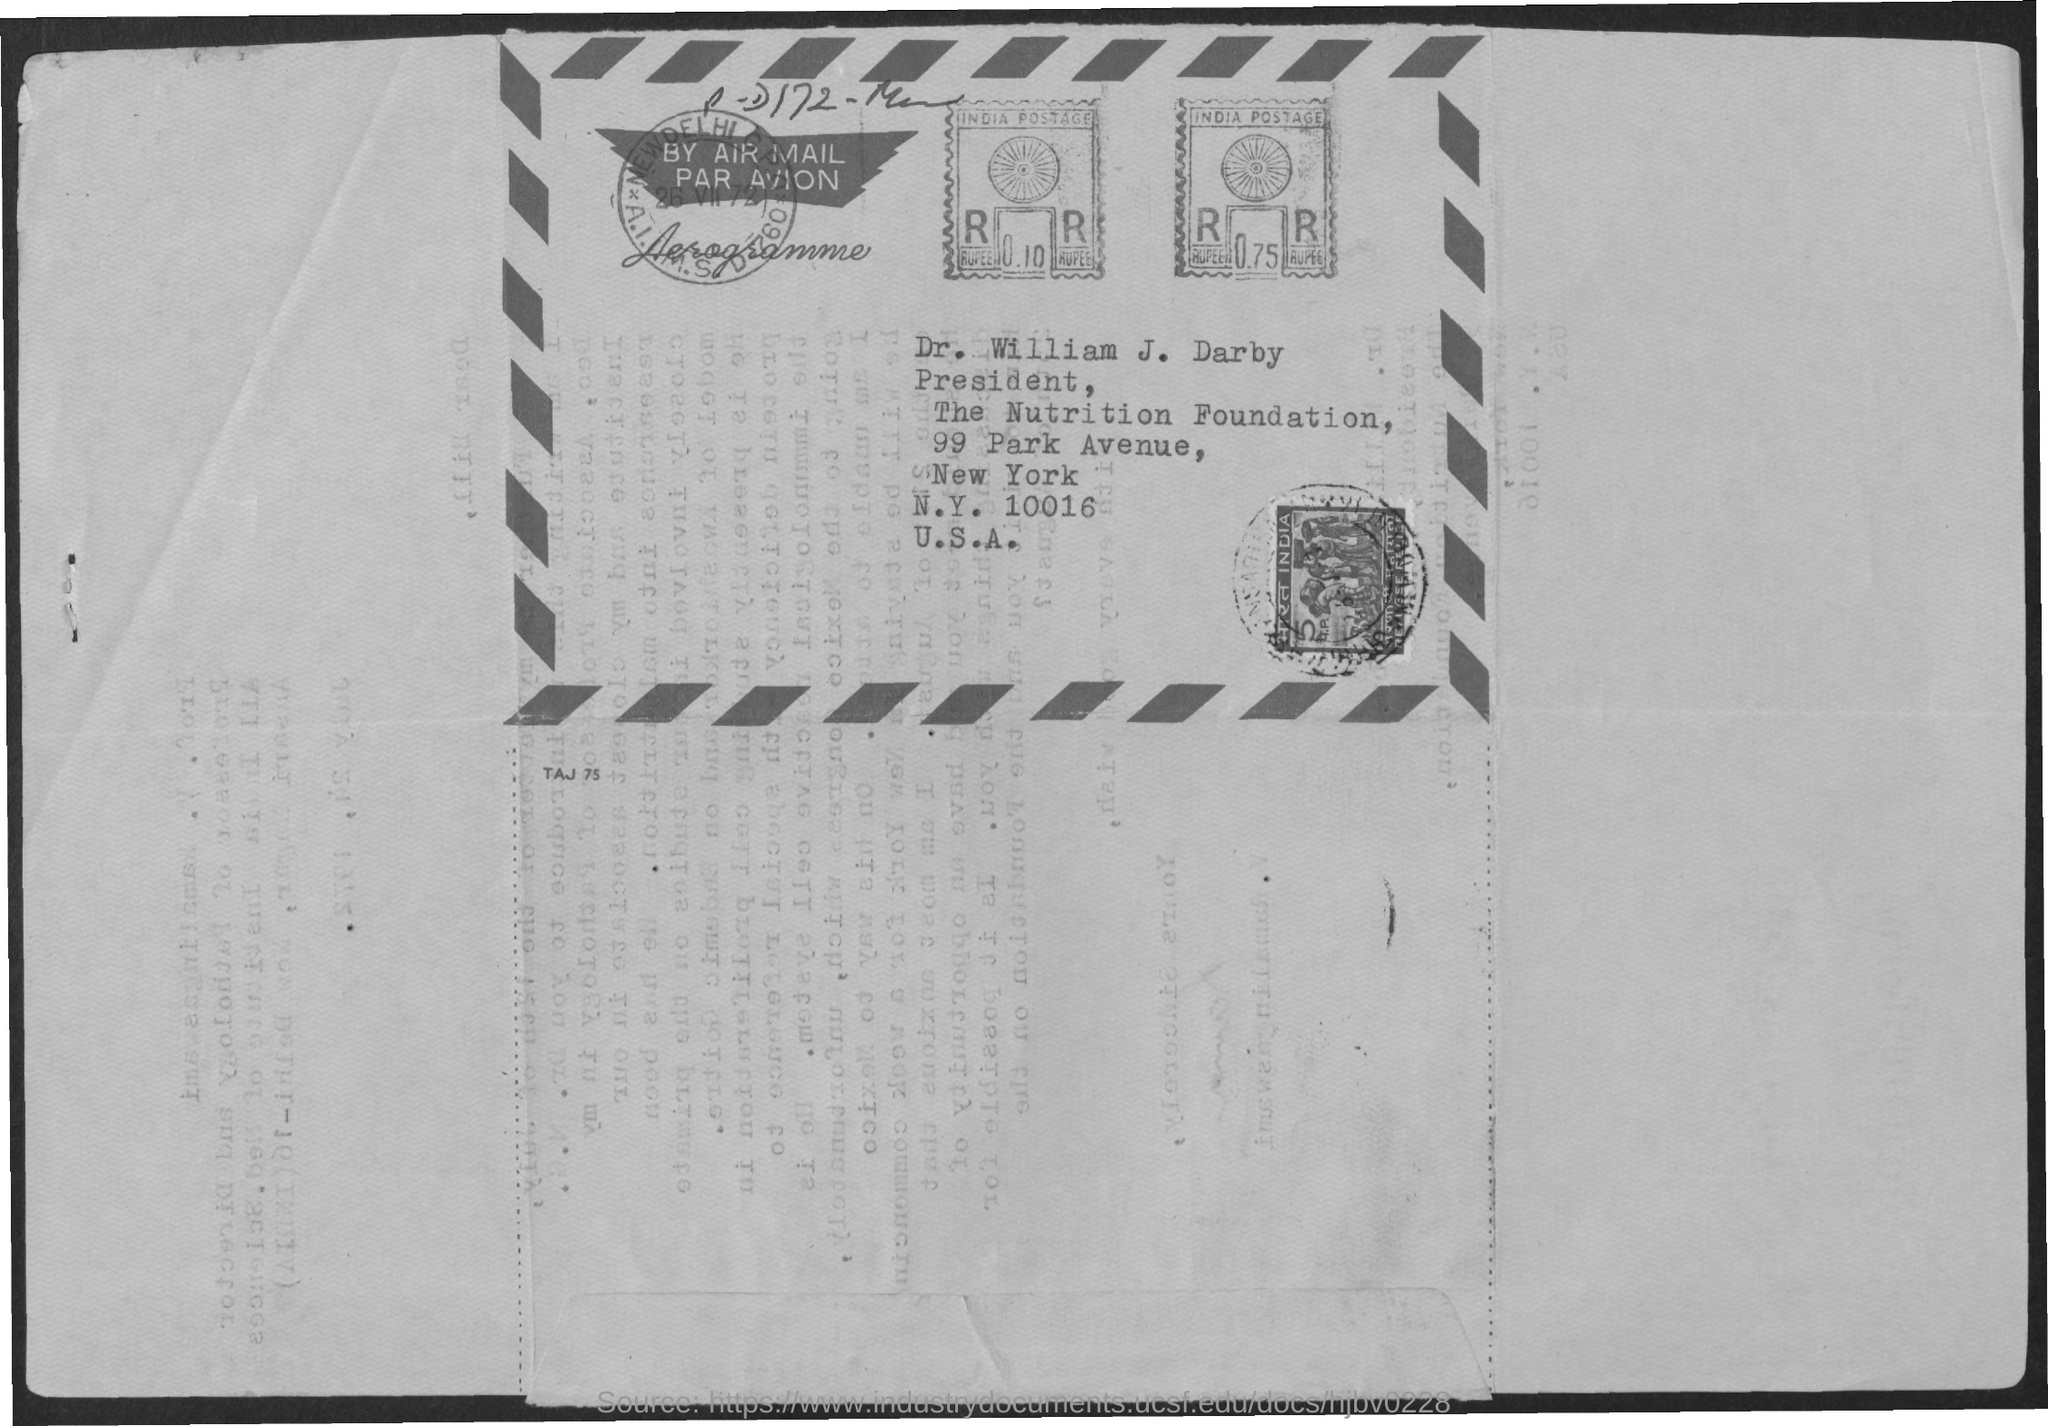Which country postage stamp is it?
Your answer should be very brief. India. Whose name is mentioned?
Your response must be concise. Dr. william j. darby. What is the designation of Dr. William J. Darby?
Offer a terse response. President. What is the zipcode mentioned?
Provide a short and direct response. 10016. What is the street address mentioned?
Make the answer very short. 99 park avenue. 